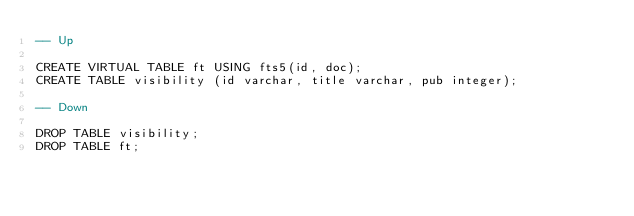<code> <loc_0><loc_0><loc_500><loc_500><_SQL_>-- Up

CREATE VIRTUAL TABLE ft USING fts5(id, doc);
CREATE TABLE visibility (id varchar, title varchar, pub integer);

-- Down

DROP TABLE visibility;
DROP TABLE ft;

</code> 